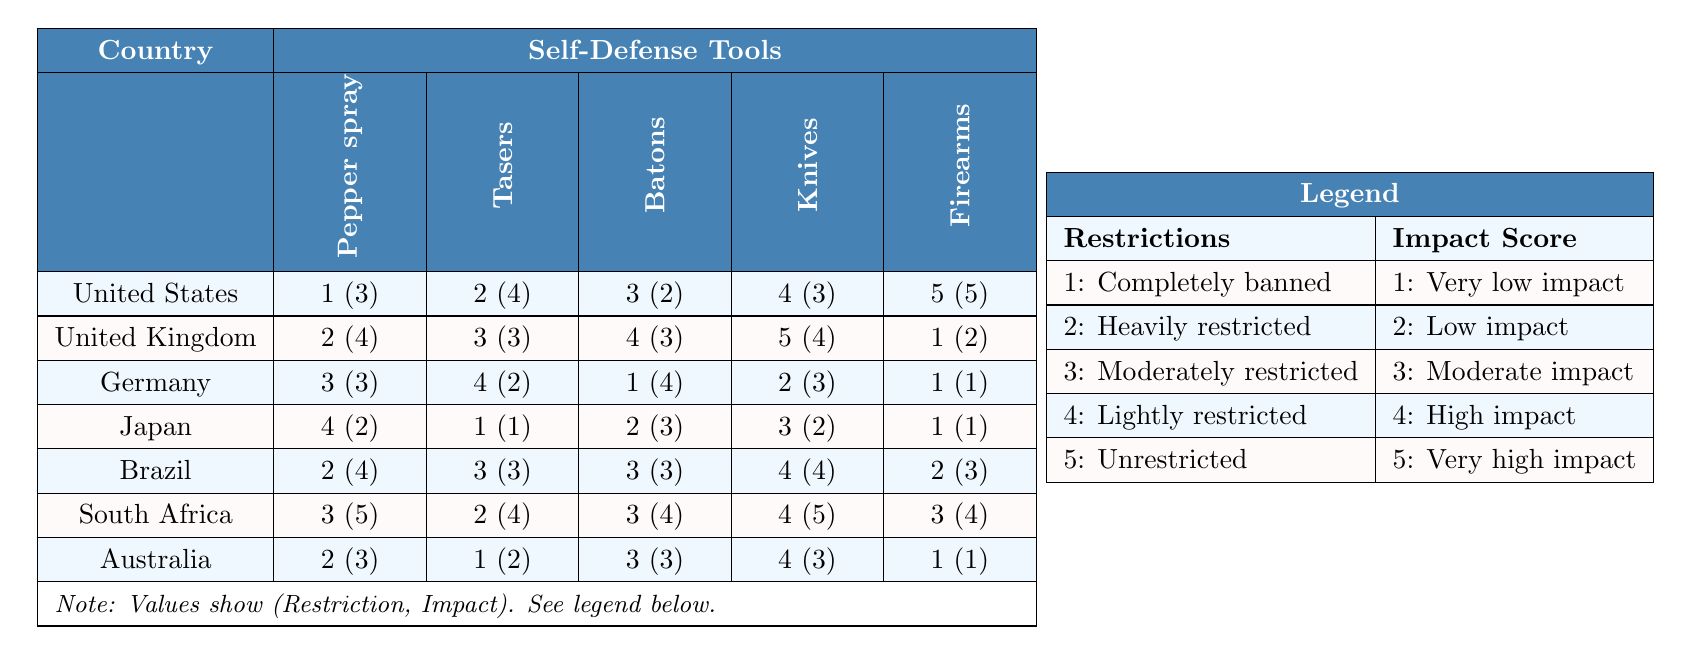What is the restriction level for firearms in the United States? In the table under the "United States" row, looking at the "Firearms" column, the value is 5, which corresponds to "Unrestricted."
Answer: Unrestricted Which country has the highest impact score for pepper spray? The impact scores for pepper spray are: United States (3), United Kingdom (4), Germany (3), Japan (2), Brazil (4), South Africa (5), and Australia (3). The highest score is 5, which is for South Africa.
Answer: South Africa Is pepper spray completely banned in Germany? In the German row under the "Pepper spray" column, the restriction is 3 which means it is "Moderately restricted." Thus, it is not completely banned.
Answer: No How many self-defense tools are completely banned in the UK? In the UK row, the restriction levels are: Pepper spray (2), Tasers (3), Batons (4), Knives (5), and Firearms (1). Only Firearms have a restriction level of 1 (completely banned), leading to a total of 1 tool.
Answer: 1 Which country has the lowest impact score for forks? The table does not contain data for forks; therefore, we cannot determine its impact score.
Answer: Not applicable What is the average restriction level for self-defense tools in Brazil? The restriction levels for Brazil are: Pepper spray (2), Tasers (3), Batons (3), Knives (4), Firearms (2). Summing these gives 2 + 3 + 3 + 4 + 2 = 14. Dividing by 5 (the number of tools) gives an average of 14/5 = 2.8, which rounds to approximately 3 (Moderately restricted).
Answer: Approximately 3 Which country has the most restrictive regulations on Tasers? For Tasers, the restriction levels are: US (2), UK (3), Germany (4), Japan (1), Brazil (3), South Africa (2), and Australia (1). The country with the highest number is Germany at 4.
Answer: Germany What is the restriction status of knives in Japan? In Japan's row under the "Knives" column, the restriction level is 3, which indicates it is "Moderately restricted."
Answer: Moderately restricted Which country has the highest number of tools that are heavily restricted? The countries with heavily restricted self-defense tools (restriction 2) are: US (1), UK (1), Germany (0), Japan (0), Brazil (1), South Africa (1), and Australia (1). The highest is 1 tool in 5 different countries, hence no country has the highest count of more than 1.
Answer: Multiple countries How do the overall impact scores compare between US and Brazil? United States has an average impact score calculated from the numbers: Pepper spray (3), Tasers (4), Batons (2), Knives (3), Firearms (5) = (3 + 4 + 2 + 3 + 5) / 5 = 3.4. For Brazil: Pepper spray (4), Tasers (3), Batons (3), Knives (4), Firearms (3) = (4 + 3 + 3 + 4 + 3) / 5 = 3.4. Both have the same average impact score of 3.4.
Answer: They are the same 